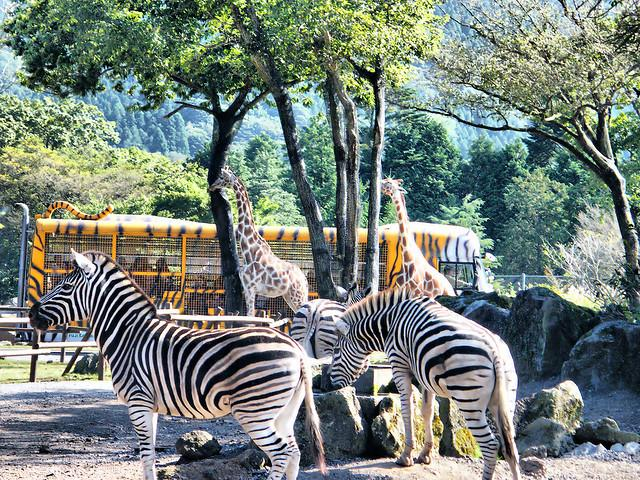What kind of vehicle is the yellow thing? Please explain your reasoning. tour bus. It is a non-tracked road vehicle that is designed to carry passengers. the vehicle is at a zoo and has an animal-themed livery, so it is used by people visiting the zoo. 